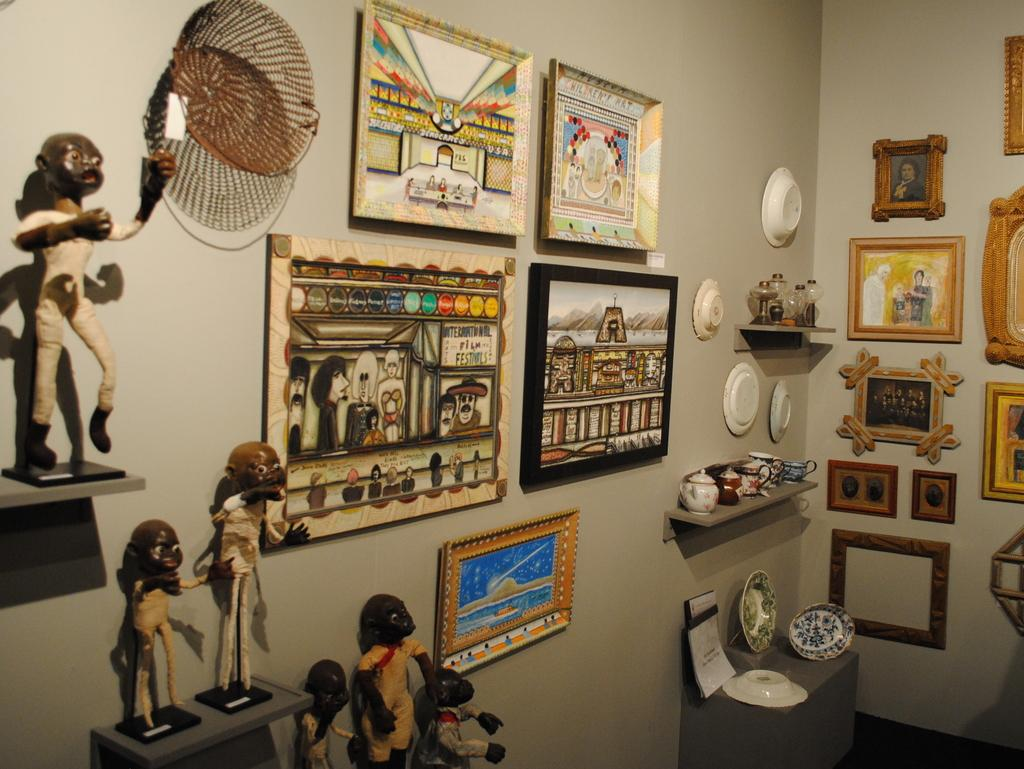What objects are on the table in the image? There are statues and plates on the table in the image. What can be seen on the wall in the image? There are photo frames and plates on the wall in the image. How many pigs are visible in the image? There are no pigs present in the image. What type of finger can be seen holding the photo frame in the image? There is no finger holding the photo frame in the image, as it is mounted on the wall. 